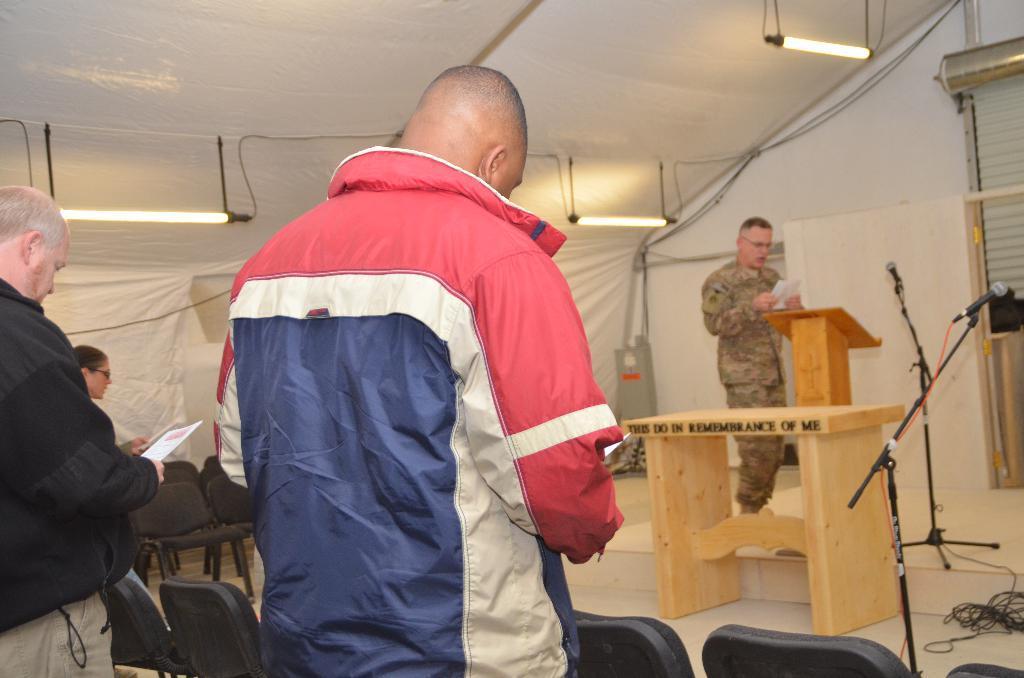Could you give a brief overview of what you see in this image? There are group of man standing under tent holding papers and few chairs are placed on room. Other side there are tables placed. 